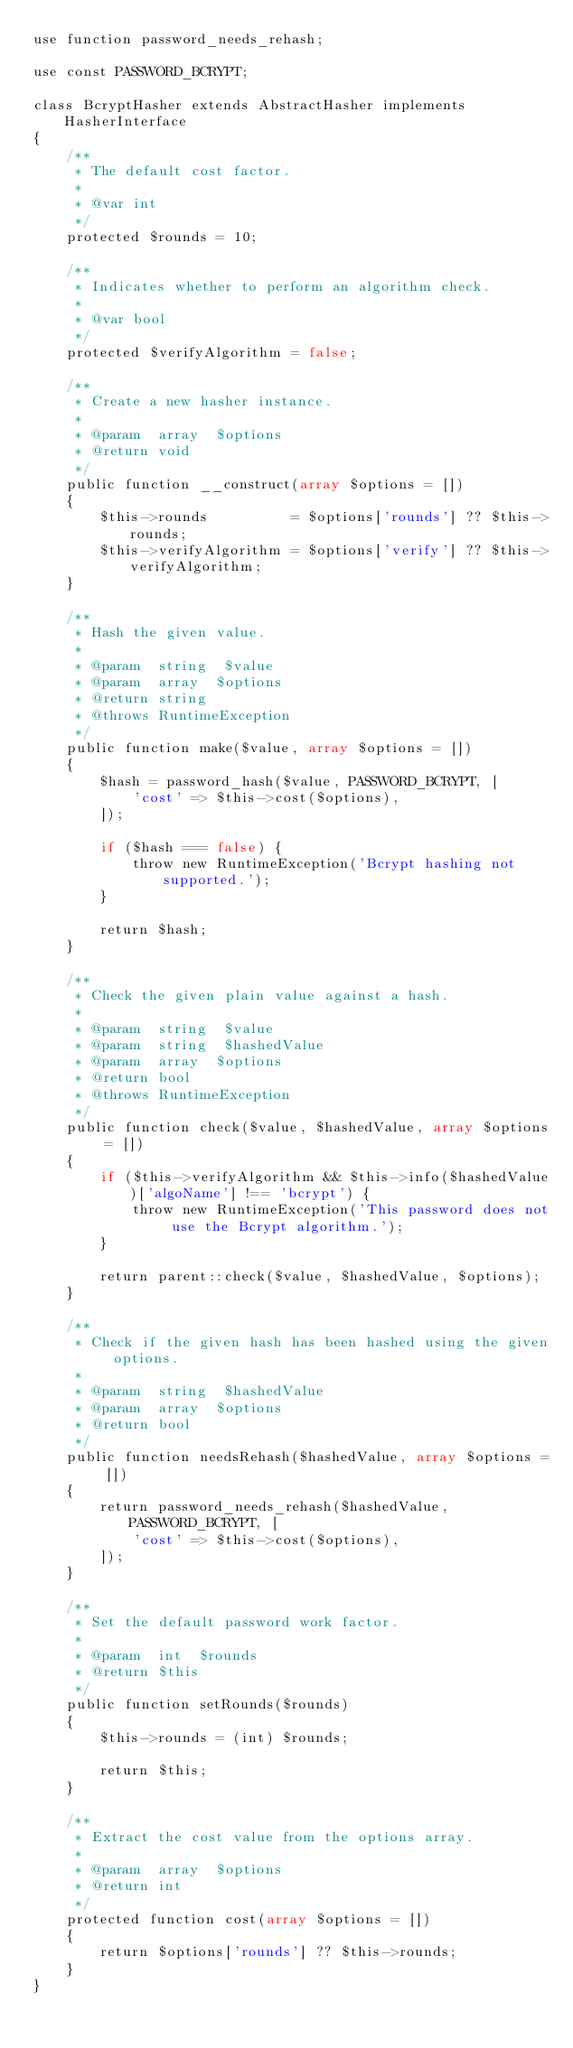Convert code to text. <code><loc_0><loc_0><loc_500><loc_500><_PHP_>use function password_needs_rehash;

use const PASSWORD_BCRYPT;

class BcryptHasher extends AbstractHasher implements HasherInterface
{
    /**
     * The default cost factor.
     *
     * @var int
     */
    protected $rounds = 10;

    /**
     * Indicates whether to perform an algorithm check.
     *
     * @var bool
     */
    protected $verifyAlgorithm = false;

    /**
     * Create a new hasher instance.
     *
     * @param  array  $options
     * @return void
     */
    public function __construct(array $options = [])
    {
        $this->rounds          = $options['rounds'] ?? $this->rounds;
        $this->verifyAlgorithm = $options['verify'] ?? $this->verifyAlgorithm;
    }

    /**
     * Hash the given value.
     *
     * @param  string  $value
     * @param  array  $options
     * @return string
     * @throws RuntimeException
     */
    public function make($value, array $options = [])
    {
        $hash = password_hash($value, PASSWORD_BCRYPT, [
            'cost' => $this->cost($options),
        ]);

        if ($hash === false) {
            throw new RuntimeException('Bcrypt hashing not supported.');
        }

        return $hash;
    }

    /**
     * Check the given plain value against a hash.
     *
     * @param  string  $value
     * @param  string  $hashedValue
     * @param  array  $options
     * @return bool
     * @throws RuntimeException
     */
    public function check($value, $hashedValue, array $options = [])
    {
        if ($this->verifyAlgorithm && $this->info($hashedValue)['algoName'] !== 'bcrypt') {
            throw new RuntimeException('This password does not use the Bcrypt algorithm.');
        }

        return parent::check($value, $hashedValue, $options);
    }

    /**
     * Check if the given hash has been hashed using the given options.
     *
     * @param  string  $hashedValue
     * @param  array  $options
     * @return bool
     */
    public function needsRehash($hashedValue, array $options = [])
    {
        return password_needs_rehash($hashedValue, PASSWORD_BCRYPT, [
            'cost' => $this->cost($options),
        ]);
    }

    /**
     * Set the default password work factor.
     *
     * @param  int  $rounds
     * @return $this
     */
    public function setRounds($rounds)
    {
        $this->rounds = (int) $rounds;

        return $this;
    }

    /**
     * Extract the cost value from the options array.
     *
     * @param  array  $options
     * @return int
     */
    protected function cost(array $options = [])
    {
        return $options['rounds'] ?? $this->rounds;
    }
}
</code> 